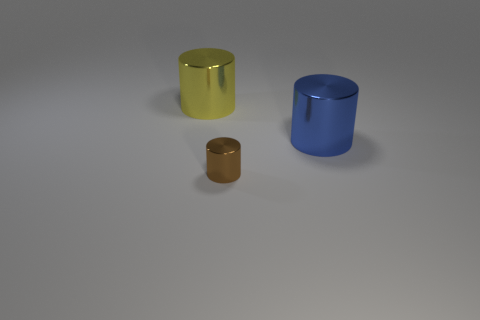Subtract all small cylinders. How many cylinders are left? 2 Add 3 tiny cyan shiny spheres. How many objects exist? 6 Subtract all yellow cylinders. How many cylinders are left? 2 Subtract all green cylinders. Subtract all yellow blocks. How many cylinders are left? 3 Subtract 1 yellow cylinders. How many objects are left? 2 Subtract all tiny brown objects. Subtract all tiny purple metal spheres. How many objects are left? 2 Add 3 big metallic objects. How many big metallic objects are left? 5 Add 3 brown things. How many brown things exist? 4 